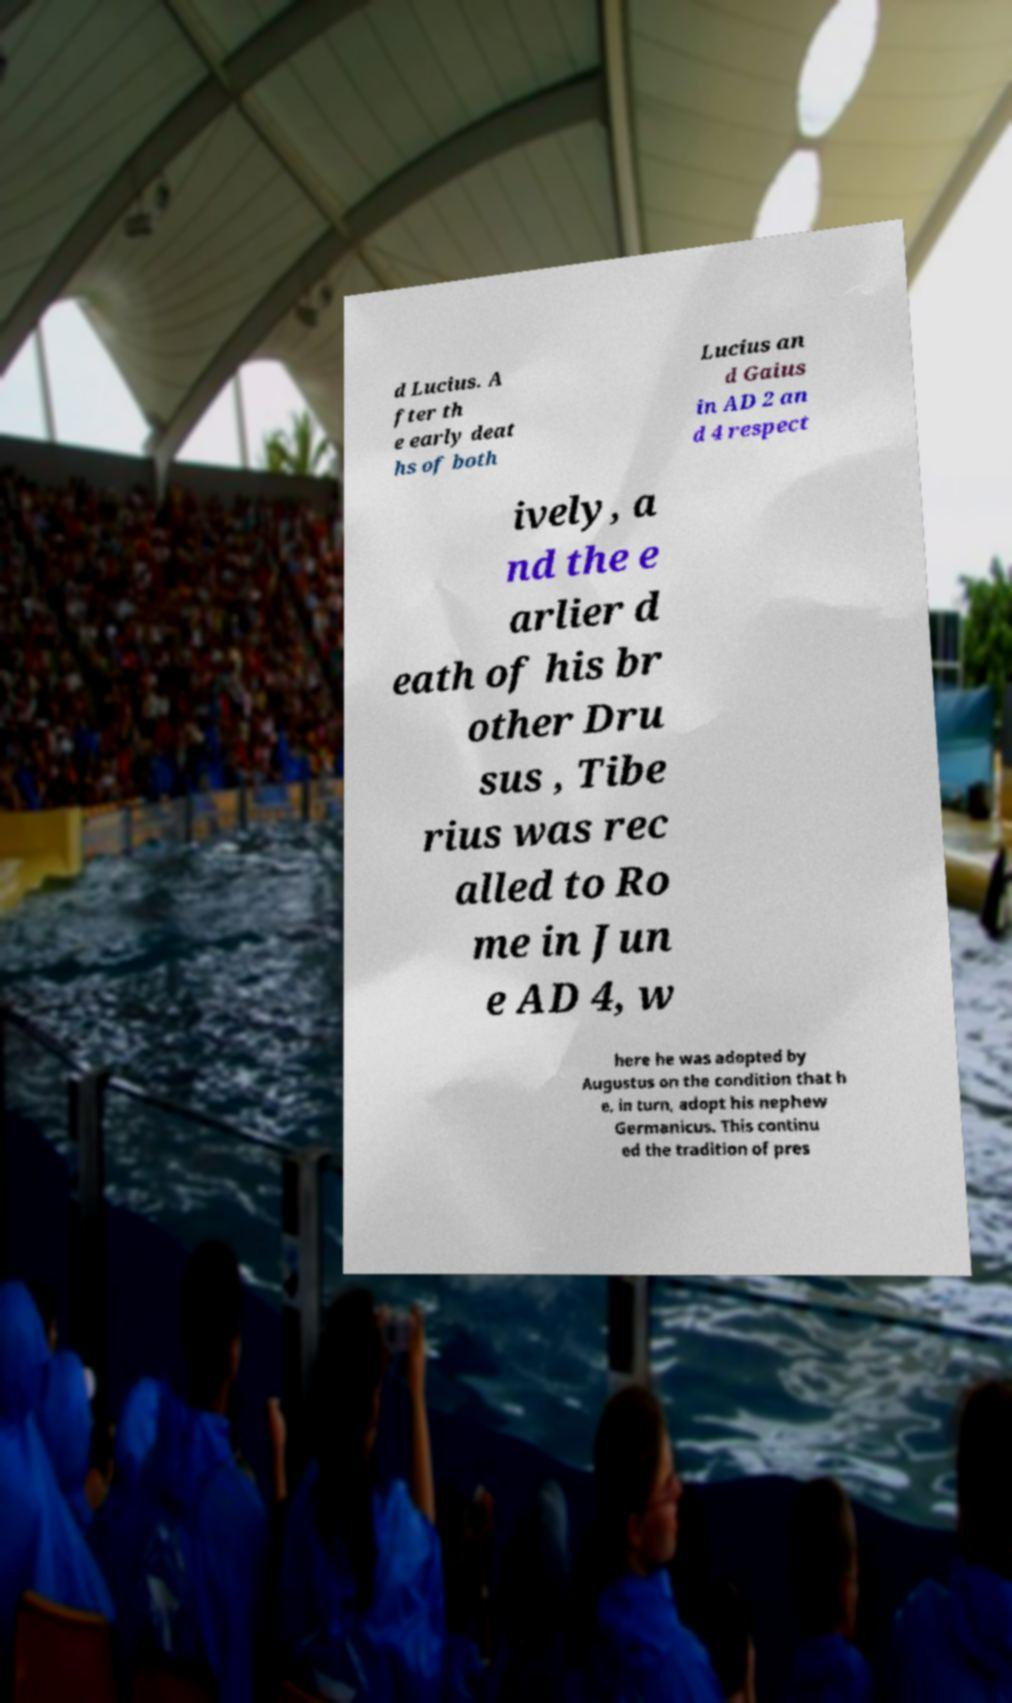Please read and relay the text visible in this image. What does it say? d Lucius. A fter th e early deat hs of both Lucius an d Gaius in AD 2 an d 4 respect ively, a nd the e arlier d eath of his br other Dru sus , Tibe rius was rec alled to Ro me in Jun e AD 4, w here he was adopted by Augustus on the condition that h e, in turn, adopt his nephew Germanicus. This continu ed the tradition of pres 